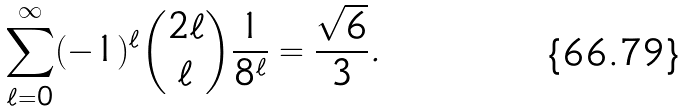Convert formula to latex. <formula><loc_0><loc_0><loc_500><loc_500>\sum _ { \ell = 0 } ^ { \infty } ( - 1 ) ^ { \ell } \binom { 2 \ell } { \ell } \frac { 1 } { 8 ^ { \ell } } = \frac { \sqrt { 6 } } { 3 } .</formula> 